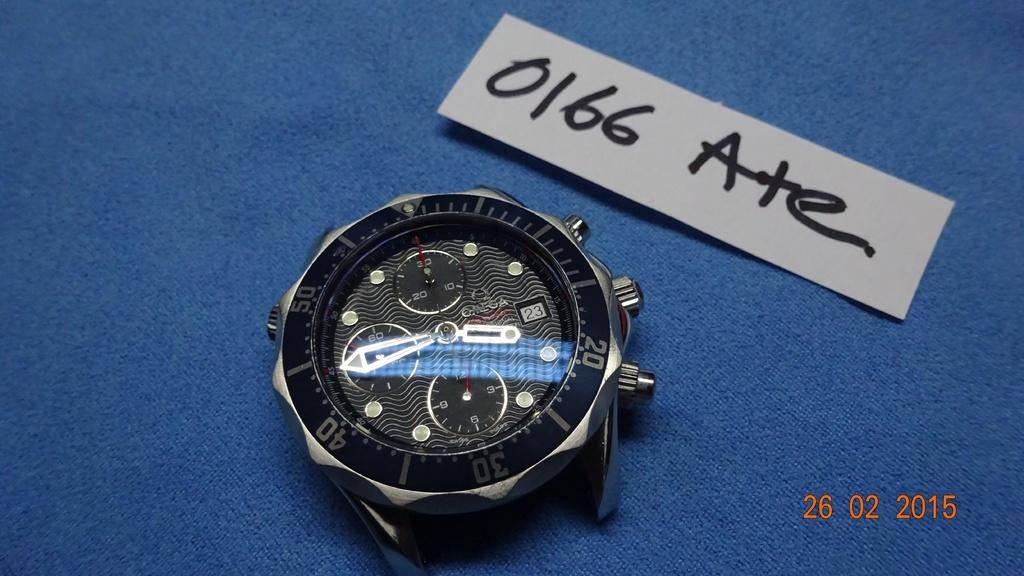<image>
Summarize the visual content of the image. A photo of a watch face on a blue background was taken on February 26, 2015. 